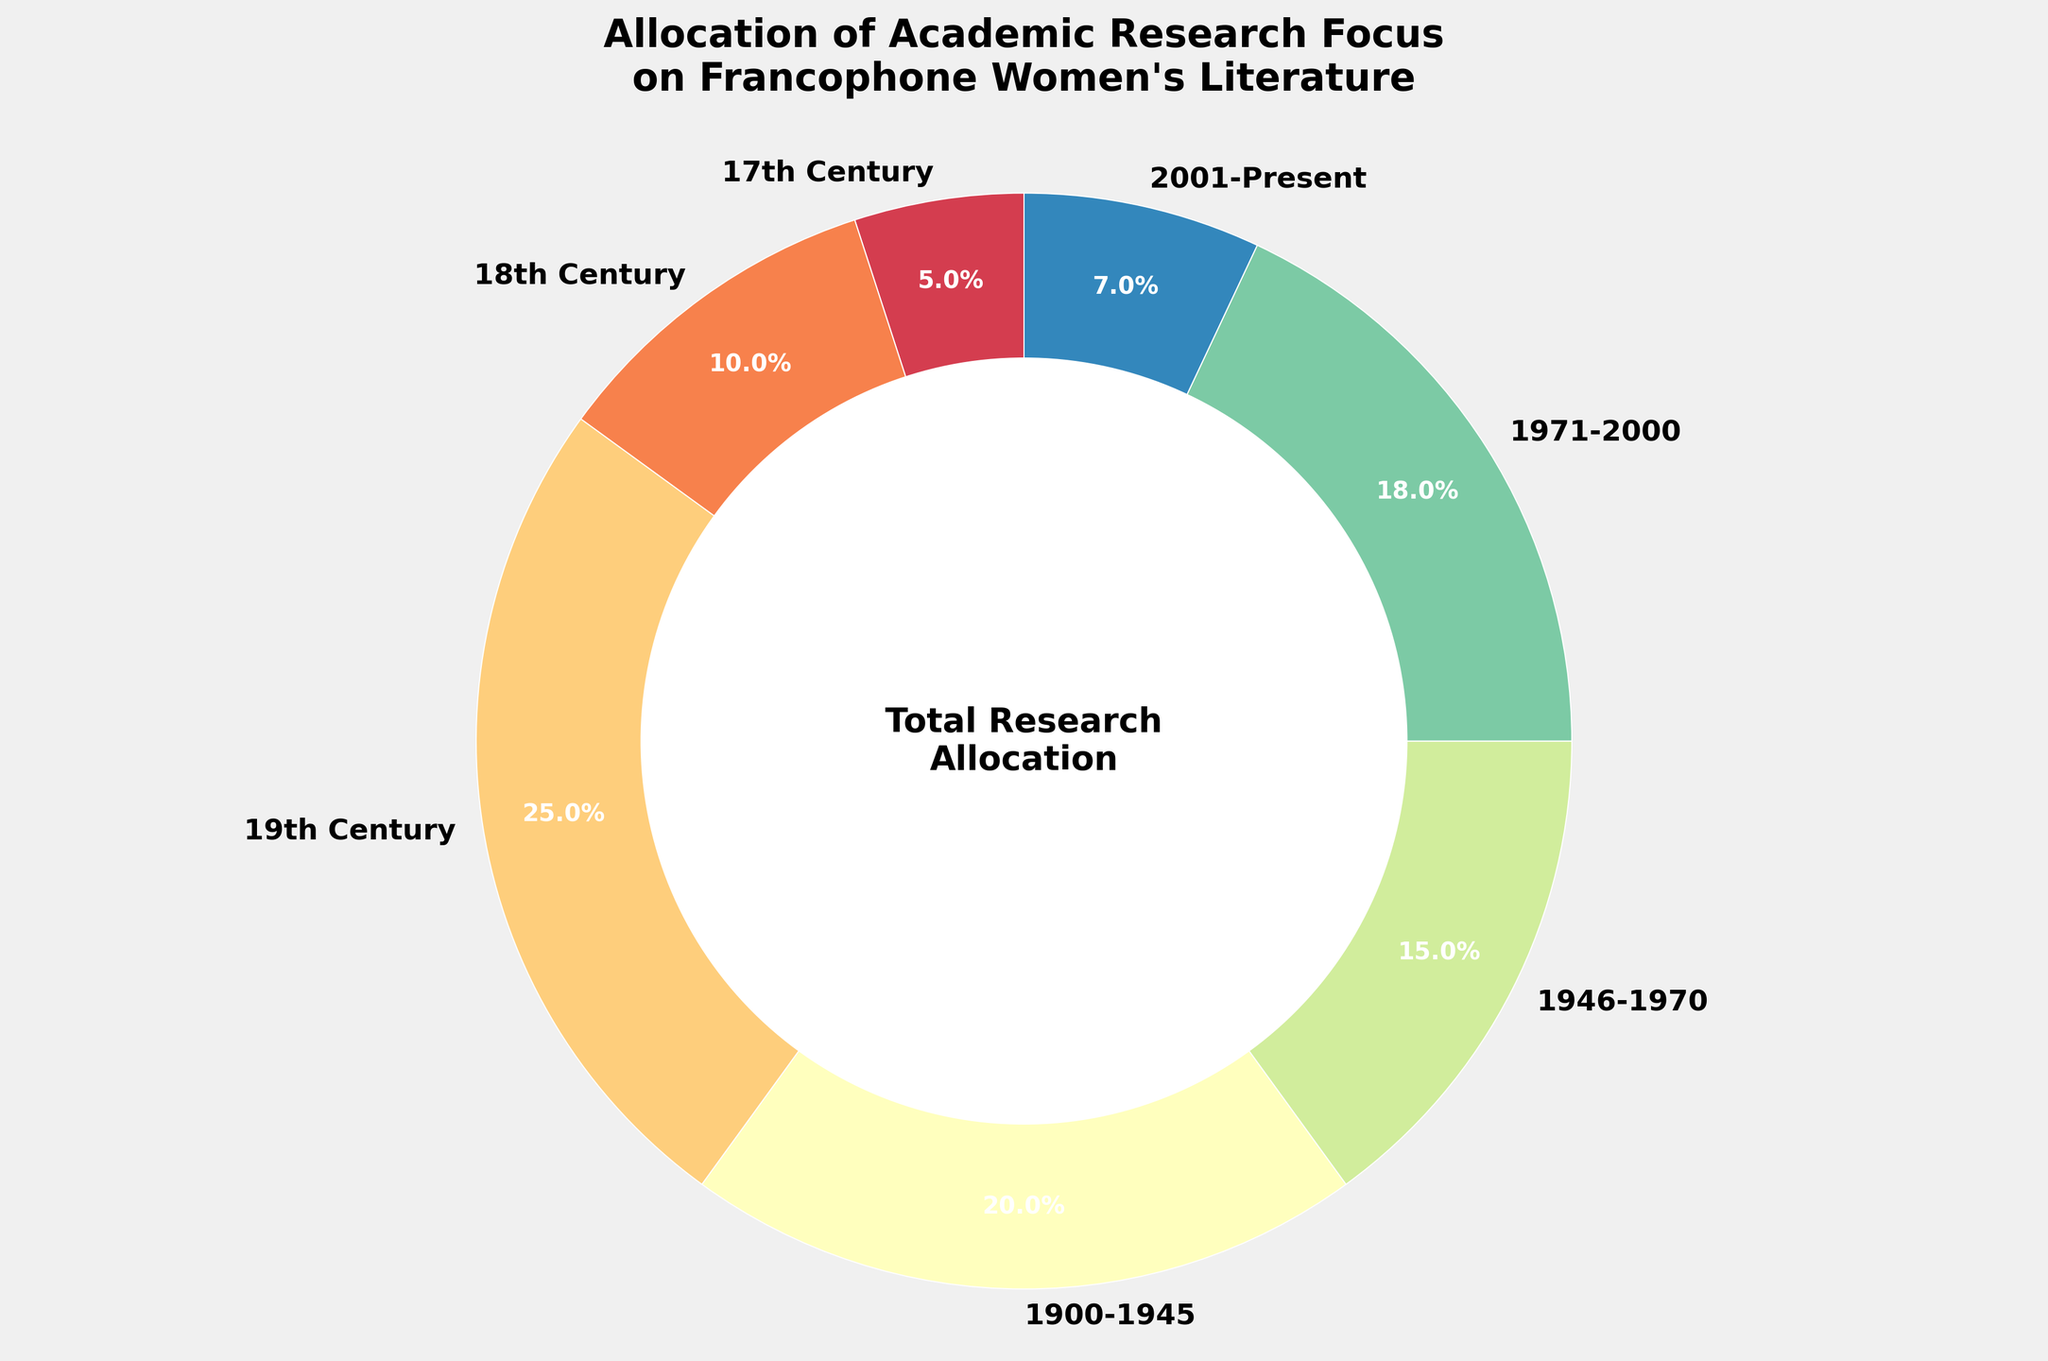Which time period has the highest allocation of academic research focus? The pie chart shows that the 19th Century has the largest wedge, indicating the highest percentage of research focus.
Answer: 19th Century How does the percentage of research focus in the 18th Century compare to the 2001-Present period? The chart shows that the 18th Century has a wedge representing 10% whereas the 2001-Present period shows a wedge representing 7%. Thus, the 18th Century has a higher percentage of research focus.
Answer: 18th Century > 2001-Present What is the sum of the research focus percentages allocated to the 17th and 18th Centuries? The chart indicates that the 17th Century has a focus of 5% and the 18th Century has a focus of 10%. Adding these together gives 5% + 10% = 15%.
Answer: 15% What is the difference in research focus between the period of 1900-1945 and the present (2001-Present)? The period 1900-1945 has a research focus of 20% while the 2001-Present has 7%. Subtracting these yields 20% - 7% = 13%.
Answer: 13% Which period has the smallest allocation of research focus, and what percentage does it represent? The chart shows that the smallest wedge belongs to the 17th Century, representing 5%.
Answer: 17th Century, 5% Is the research focus on literature from the 1946-1970 period greater than or less than that from the 1971-2000 period? The chart shows a 15% focus for 1946-1970 and an 18% focus for 1971-2000. Therefore, 1946-1970 is less than 1971-2000.
Answer: Less What percentage of research focus is dedicated to literature from the 20th Century (1900-2000)? Summing the percentages from the periods 1900-1945 (20%), 1946-1970 (15%), and 1971-2000 (18%) results in a total of 20% + 15% + 18% = 53%.
Answer: 53% Compare the research focus allocated to the 19th Century to the combined focus of 1946-1970 and 2001-Present. Which is greater and by how much? The 19th Century has 25% focus, while 1946-1970 and 2001-Present combined have 15% + 7% = 22%. The difference is 25% - 22% = 3%. Thus, the 19th Century is greater by 3%.
Answer: 19th Century by 3% What is the total research focus percentage not dedicated to the 19th Century? The total research focus is represented by the sum of all percentages minus the 19th Century's focus: 100% - 25% = 75%.
Answer: 75% 